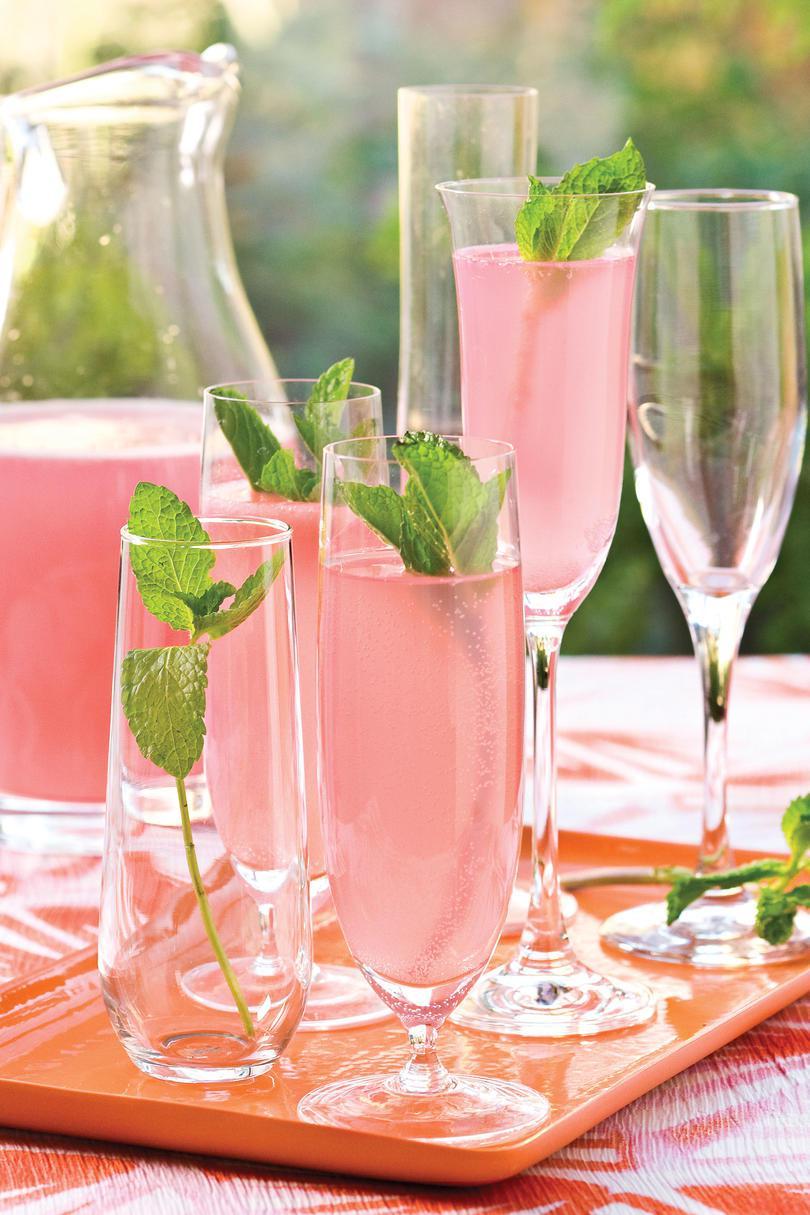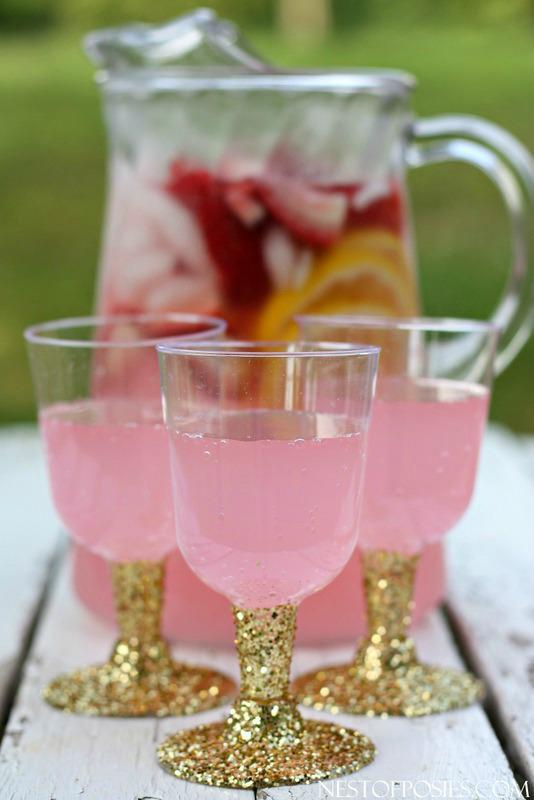The first image is the image on the left, the second image is the image on the right. For the images shown, is this caption "Both images have pink lemonade in glass dishes." true? Answer yes or no. Yes. The first image is the image on the left, the second image is the image on the right. Examine the images to the left and right. Is the description "There are straws in the right image." accurate? Answer yes or no. No. 